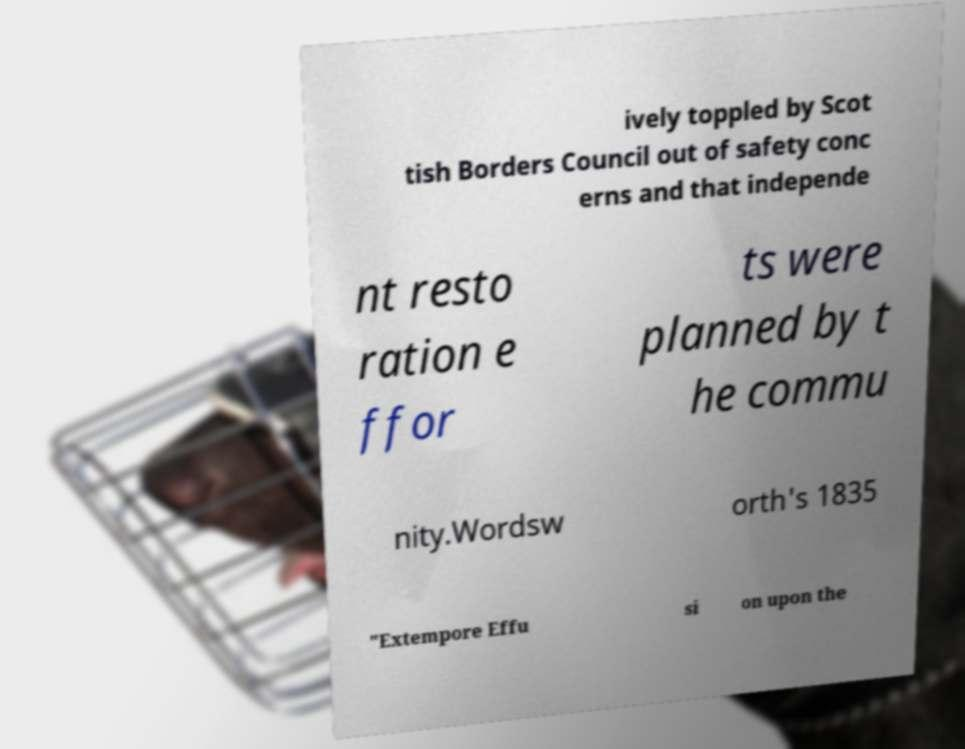Can you read and provide the text displayed in the image?This photo seems to have some interesting text. Can you extract and type it out for me? ively toppled by Scot tish Borders Council out of safety conc erns and that independe nt resto ration e ffor ts were planned by t he commu nity.Wordsw orth's 1835 "Extempore Effu si on upon the 